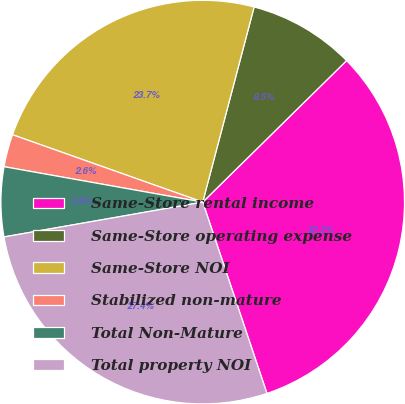Convert chart. <chart><loc_0><loc_0><loc_500><loc_500><pie_chart><fcel>Same-Store rental income<fcel>Same-Store operating expense<fcel>Same-Store NOI<fcel>Stabilized non-mature<fcel>Total Non-Mature<fcel>Total property NOI<nl><fcel>32.21%<fcel>8.53%<fcel>23.68%<fcel>2.61%<fcel>5.57%<fcel>27.39%<nl></chart> 